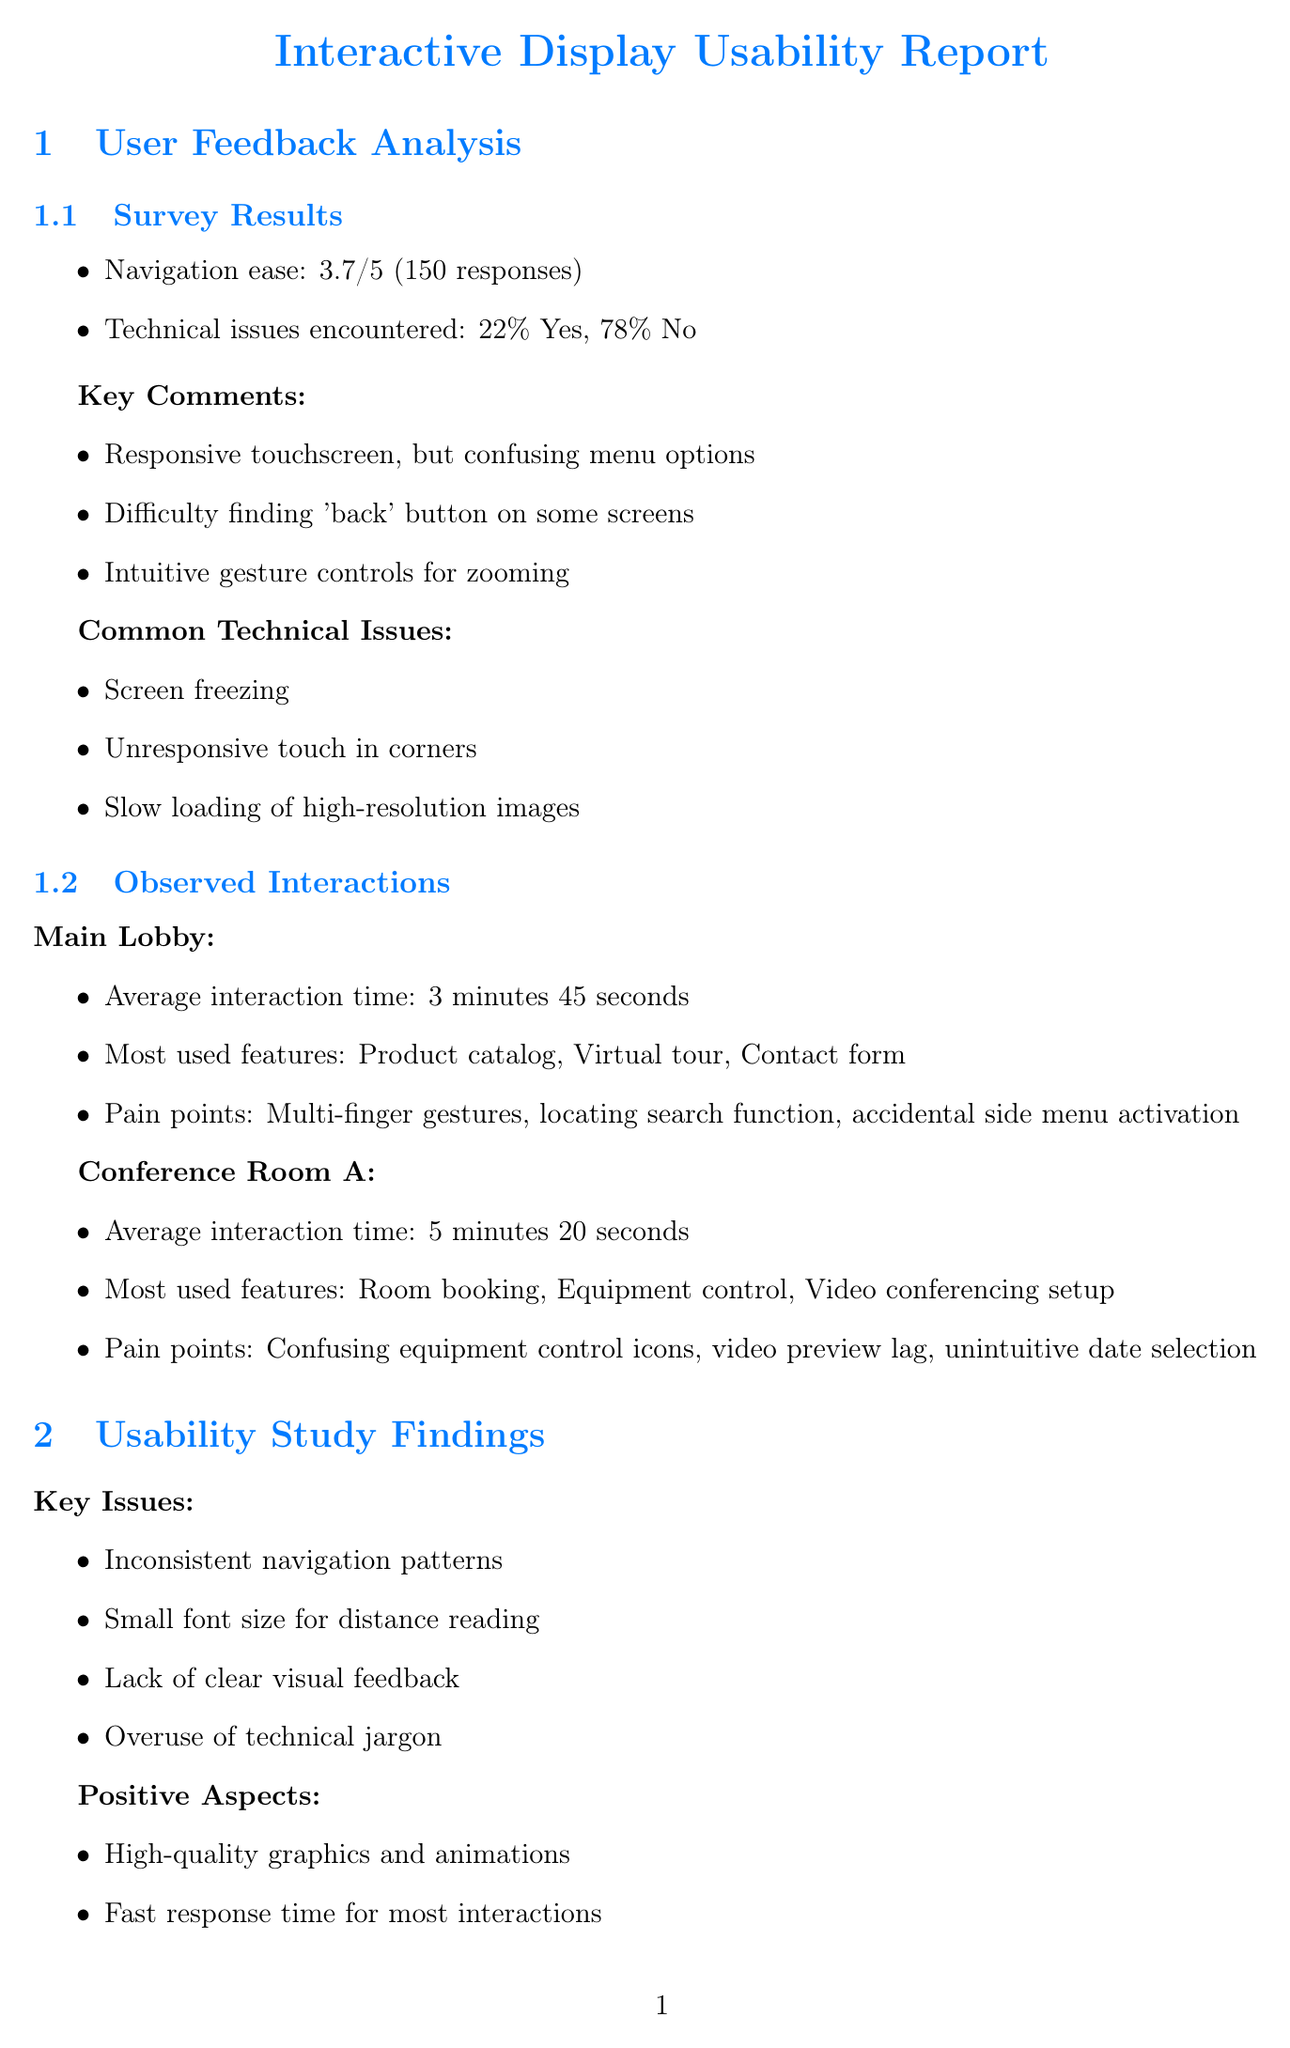What was the average rating for navigation ease? The average rating for navigation ease can be found in the survey results section of the document, which is 3.7 out of 5.
Answer: 3.7 What percentage of users encountered technical issues? The document states that 22% of users reported encountering technical issues while using the display.
Answer: 22% What are the most used features in the Main Lobby? The document lists the most used features in the Main Lobby as product catalog browsing, virtual tour, and contact form.
Answer: Product catalog browsing, virtual tour, contact form What is the priority level for addressing navigation inconsistency? The priority level for addressing navigation inconsistency is indicated in the suggested modifications section, where it is classified as high.
Answer: High What is the estimated impact of increasing the font size? The estimated impact of increasing the font size by 20% is mentioned in the suggested modifications, stating that it will improve readability for 90% of users.
Answer: 90% improved readability What is one of the positive aspects of the interactive displays? The document highlights high-quality graphics and animations as one of the positive aspects of the interactive displays.
Answer: High-quality graphics and animations What is the average interaction time in Conference Room A? The average interaction time in Conference Room A is specified in the observed interactions section, which is 5 minutes 20 seconds.
Answer: 5 minutes 20 seconds Name one proposed hardware requirement. The document includes several proposed hardware requirements; one of them is to upgrade to 4K resolution displays.
Answer: Upgrade to 4K resolution displays What accessibility improvement is suggested for users with mobility impairments? The document suggests implementing voice control options specifically for users with mobility impairments.
Answer: Implement voice control options 